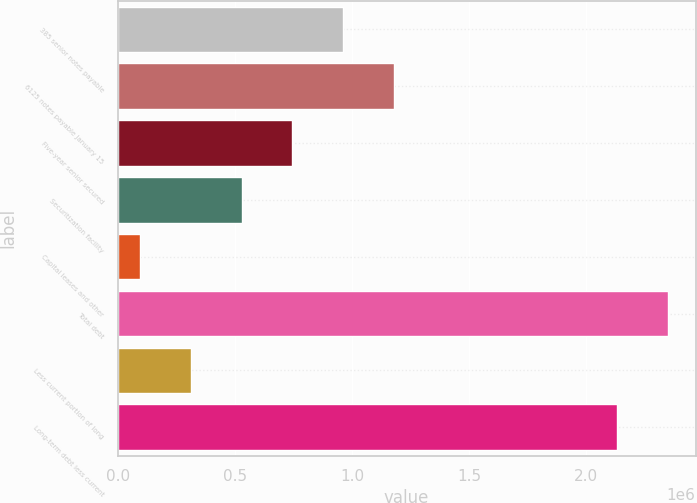<chart> <loc_0><loc_0><loc_500><loc_500><bar_chart><fcel>385 senior notes payable<fcel>6125 notes payable January 15<fcel>Five-year senior secured<fcel>Securitization facility<fcel>Capital leases and other<fcel>Total debt<fcel>Less current portion of long<fcel>Long-term debt less current<nl><fcel>961605<fcel>1.17801e+06<fcel>745204<fcel>528804<fcel>96003<fcel>2.34919e+06<fcel>312404<fcel>2.13279e+06<nl></chart> 